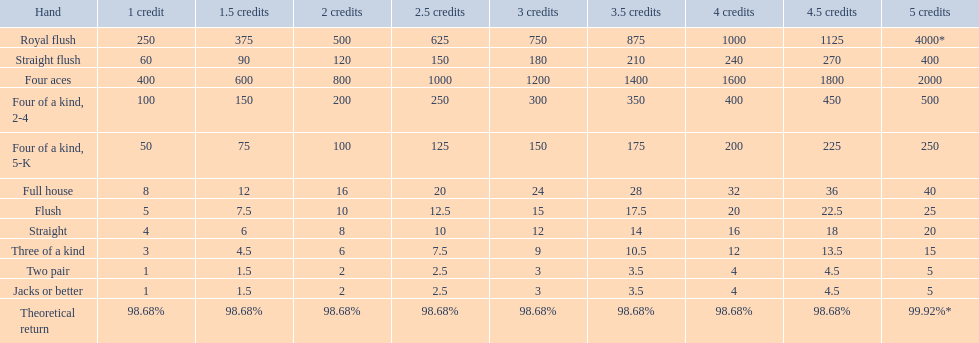What are the hands in super aces? Royal flush, Straight flush, Four aces, Four of a kind, 2-4, Four of a kind, 5-K, Full house, Flush, Straight, Three of a kind, Two pair, Jacks or better. What hand gives the highest credits? Royal flush. Can you parse all the data within this table? {'header': ['Hand', '1 credit', '1.5 credits', '2 credits', '2.5 credits', '3 credits', '3.5 credits', '4 credits', '4.5 credits', '5 credits'], 'rows': [['Royal flush', '250', '375', '500', '625', '750', '875', '1000', '1125', '4000*'], ['Straight flush', '60', '90', '120', '150', '180', '210', '240', '270', '400'], ['Four aces', '400', '600', '800', '1000', '1200', '1400', '1600', '1800', '2000'], ['Four of a kind, 2-4', '100', '150', '200', '250', '300', '350', '400', '450', '500'], ['Four of a kind, 5-K', '50', '75', '100', '125', '150', '175', '200', '225', '250'], ['Full house', '8', '12', '16', '20', '24', '28', '32', '36', '40'], ['Flush', '5', '7.5', '10', '12.5', '15', '17.5', '20', '22.5', '25'], ['Straight', '4', '6', '8', '10', '12', '14', '16', '18', '20'], ['Three of a kind', '3', '4.5', '6', '7.5', '9', '10.5', '12', '13.5', '15'], ['Two pair', '1', '1.5', '2', '2.5', '3', '3.5', '4', '4.5', '5'], ['Jacks or better', '1', '1.5', '2', '2.5', '3', '3.5', '4', '4.5', '5'], ['Theoretical return', '98.68%', '98.68%', '98.68%', '98.68%', '98.68%', '98.68%', '98.68%', '98.68%', '99.92%*']]} 